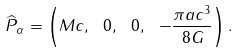Convert formula to latex. <formula><loc_0><loc_0><loc_500><loc_500>\widehat { P } _ { \alpha } = \left ( M c , \ 0 , \ 0 , \ - \frac { \pi a c ^ { 3 } } { 8 G } \right ) .</formula> 